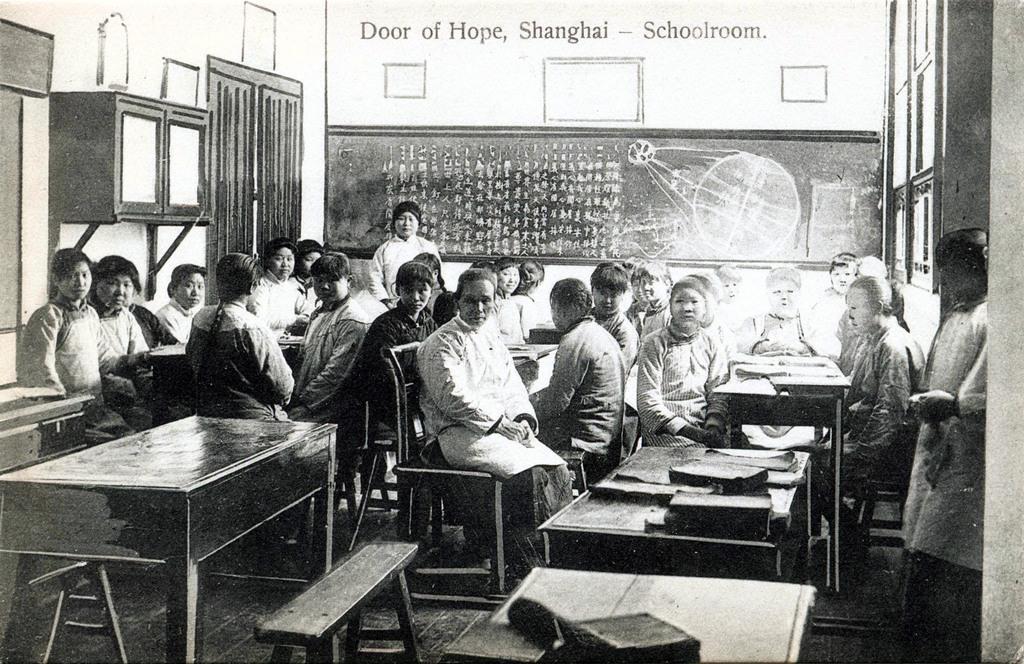Please provide a concise description of this image. In this image there are a few people sitting on the chairs and a few people standing. In front of them there are tables. On top of it there are books. In the background of the image there is a board with some text and drawing on it. On the left side of the image there is a closed door. On both right and left side of the image there are cupboards. 